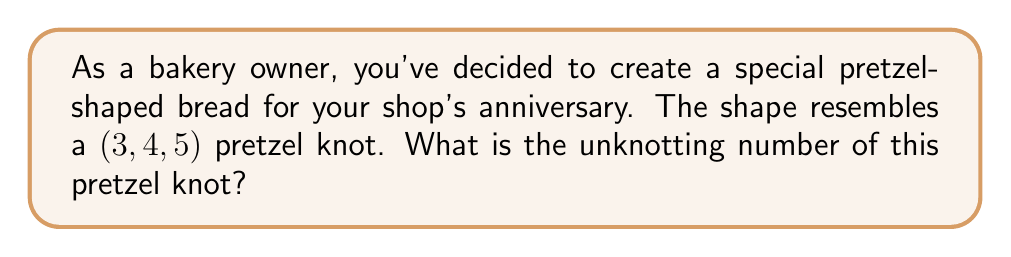Teach me how to tackle this problem. To determine the unknotting number of a $(3,4,5)$ pretzel knot, we'll follow these steps:

1. Recall that a pretzel knot $P(p,q,r)$ has an unknotting number given by:

   $$u(P(p,q,r)) = \min\{|p|, |q|, |r|, \frac{|p+q+r|-1}{2}\}$$

2. In our case, $p=3$, $q=4$, and $r=5$. Let's substitute these values:

   $$u(P(3,4,5)) = \min\{|3|, |4|, |5|, \frac{|3+4+5|-1}{2}\}$$

3. Simplify the absolute values:

   $$u(P(3,4,5)) = \min\{3, 4, 5, \frac{|12|-1}{2}\}$$

4. Calculate the last term:

   $$u(P(3,4,5)) = \min\{3, 4, 5, \frac{12-1}{2}\} = \min\{3, 4, 5, \frac{11}{2}\}$$

5. Simplify:

   $$u(P(3,4,5)) = \min\{3, 4, 5, 5.5\}$$

6. The minimum value among these is 3.

Therefore, the unknotting number of the $(3,4,5)$ pretzel knot is 3.
Answer: 3 